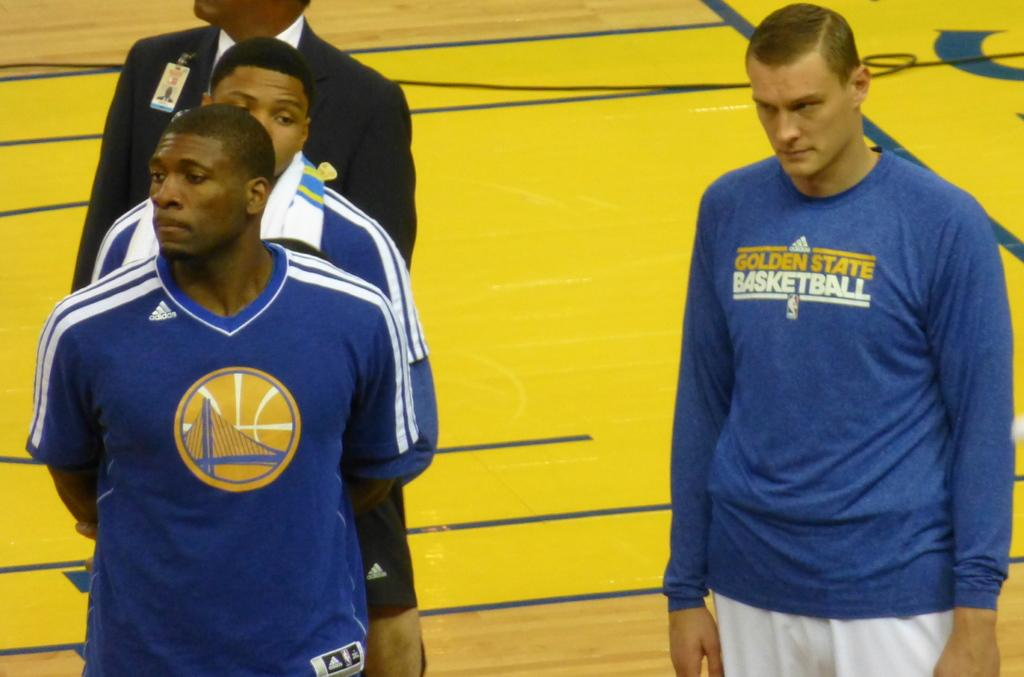<image>
Share a concise interpretation of the image provided. Golden State Warriors players wearing their warm up shirts before a basketball game. 